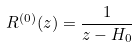Convert formula to latex. <formula><loc_0><loc_0><loc_500><loc_500>R ^ { ( 0 ) } ( z ) = \frac { 1 } { z - H _ { 0 } }</formula> 